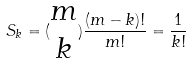Convert formula to latex. <formula><loc_0><loc_0><loc_500><loc_500>S _ { k } = ( \begin{matrix} m \\ k \end{matrix} ) \frac { ( m - k ) ! } { m ! } = \frac { 1 } { k ! }</formula> 